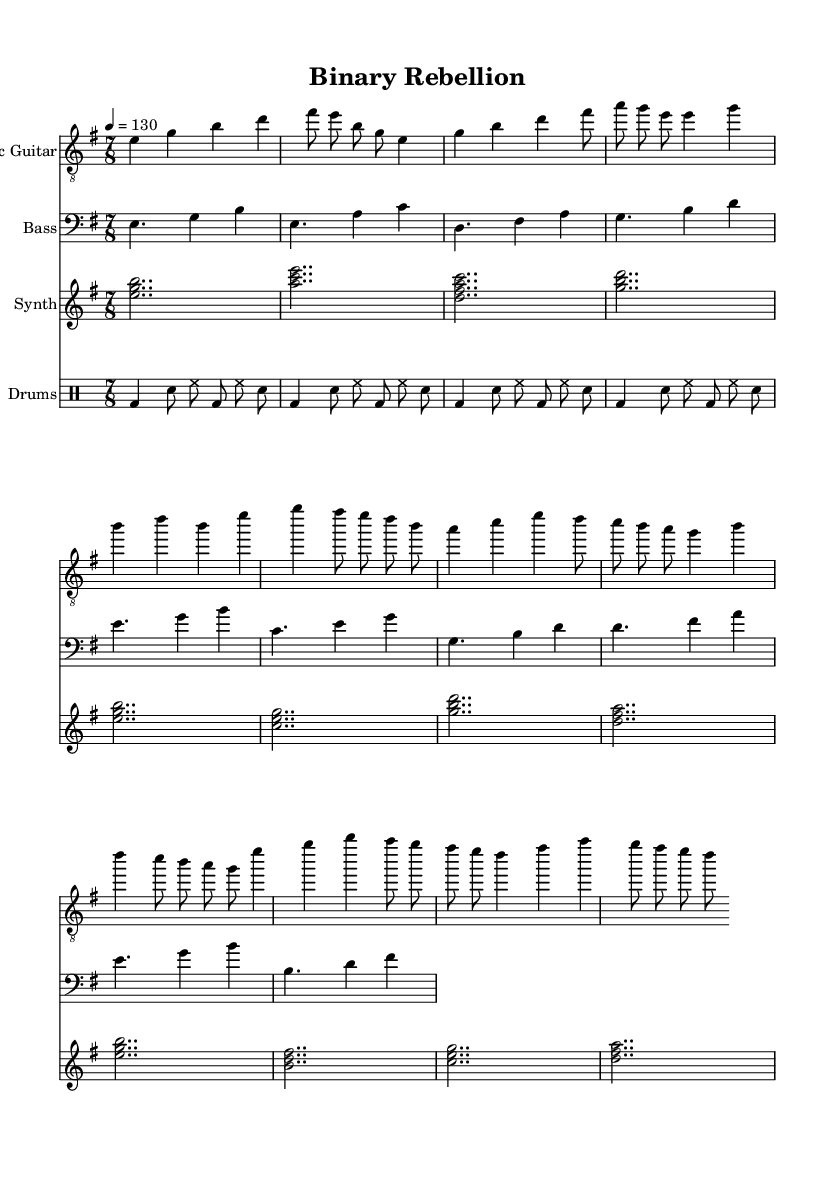What is the key signature of this music? The key signature is indicated at the beginning of the piece. It shows that there is one sharp, which corresponds to the key of E minor.
Answer: E minor What is the time signature of this music? The time signature is located at the start of the piece, where it is indicated as 7/8, meaning there are seven beats in each measure and the eighth note gets one beat.
Answer: 7/8 What is the tempo marking indicated for this piece? The tempo marking is found in the header section of the score, showing a metronome marking of quarter note equals 130 beats per minute.
Answer: 130 How many different sections are there in this composition? By observing the various named sections in the music (Intro, Verse, Chorus), we can identify three distinct sections in the piece.
Answer: Three During the chorus, what is the highest note played on the electric guitar? In the chorus part, we look for the highest pitch indicated in the electric guitar section. The highest note, 'g', appears in an eighth note position.
Answer: g What is the primary instrumentation used in this composition? The instrumentation can be determined by examining the score's staff names. It consists of Electric Guitar, Bass, Synth, and Drums, indicating a typical fusion setup.
Answer: Electric Guitar, Bass, Synth, Drums How does the drum pattern relate to the time signature? Analyzing the drum part shows that it fits within the 7/8 time signature, with accents placed on the first beat and maintaining a rhythmic complexity that aligns with the odd time signature.
Answer: It fits within the 7/8 time signature 